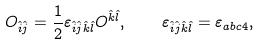<formula> <loc_0><loc_0><loc_500><loc_500>O _ { \hat { i } \hat { j } } = \frac { 1 } { 2 } \varepsilon _ { \hat { i } \hat { j } \hat { k } \hat { l } } O ^ { \hat { k } \hat { l } } , \quad \varepsilon _ { \hat { i } \hat { j } \hat { k } \hat { l } } = \varepsilon _ { a b c 4 } ,</formula> 